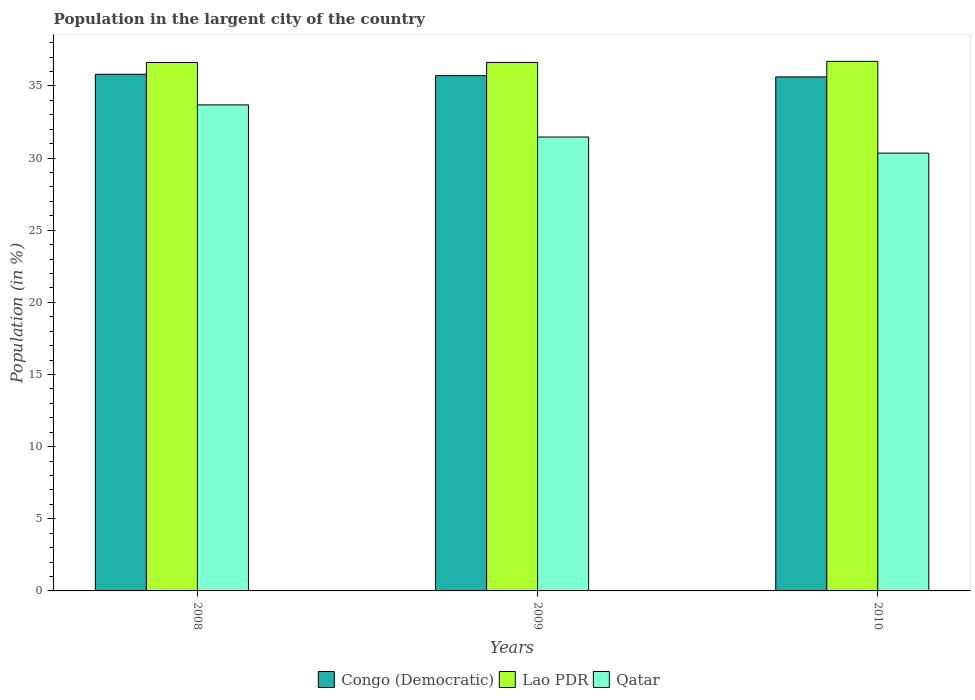How many different coloured bars are there?
Keep it short and to the point. 3. How many groups of bars are there?
Keep it short and to the point. 3. Are the number of bars per tick equal to the number of legend labels?
Make the answer very short. Yes. Are the number of bars on each tick of the X-axis equal?
Your response must be concise. Yes. How many bars are there on the 2nd tick from the right?
Offer a very short reply. 3. What is the label of the 1st group of bars from the left?
Ensure brevity in your answer.  2008. What is the percentage of population in the largent city in Congo (Democratic) in 2008?
Offer a terse response. 35.81. Across all years, what is the maximum percentage of population in the largent city in Congo (Democratic)?
Offer a terse response. 35.81. Across all years, what is the minimum percentage of population in the largent city in Congo (Democratic)?
Offer a terse response. 35.63. In which year was the percentage of population in the largent city in Congo (Democratic) maximum?
Your answer should be compact. 2008. What is the total percentage of population in the largent city in Lao PDR in the graph?
Give a very brief answer. 109.96. What is the difference between the percentage of population in the largent city in Qatar in 2009 and that in 2010?
Your answer should be very brief. 1.12. What is the difference between the percentage of population in the largent city in Lao PDR in 2008 and the percentage of population in the largent city in Congo (Democratic) in 2010?
Offer a terse response. 1. What is the average percentage of population in the largent city in Congo (Democratic) per year?
Provide a succinct answer. 35.72. In the year 2010, what is the difference between the percentage of population in the largent city in Qatar and percentage of population in the largent city in Congo (Democratic)?
Make the answer very short. -5.28. In how many years, is the percentage of population in the largent city in Congo (Democratic) greater than 21 %?
Offer a very short reply. 3. What is the ratio of the percentage of population in the largent city in Lao PDR in 2009 to that in 2010?
Your answer should be very brief. 1. Is the percentage of population in the largent city in Lao PDR in 2008 less than that in 2010?
Keep it short and to the point. Yes. What is the difference between the highest and the second highest percentage of population in the largent city in Qatar?
Your answer should be compact. 2.23. What is the difference between the highest and the lowest percentage of population in the largent city in Lao PDR?
Your response must be concise. 0.08. In how many years, is the percentage of population in the largent city in Qatar greater than the average percentage of population in the largent city in Qatar taken over all years?
Offer a terse response. 1. What does the 1st bar from the left in 2009 represents?
Your answer should be very brief. Congo (Democratic). What does the 3rd bar from the right in 2009 represents?
Make the answer very short. Congo (Democratic). Is it the case that in every year, the sum of the percentage of population in the largent city in Lao PDR and percentage of population in the largent city in Congo (Democratic) is greater than the percentage of population in the largent city in Qatar?
Provide a succinct answer. Yes. How many bars are there?
Your answer should be very brief. 9. What is the difference between two consecutive major ticks on the Y-axis?
Give a very brief answer. 5. Does the graph contain any zero values?
Offer a terse response. No. Does the graph contain grids?
Your response must be concise. No. How many legend labels are there?
Provide a short and direct response. 3. What is the title of the graph?
Give a very brief answer. Population in the largent city of the country. What is the label or title of the X-axis?
Ensure brevity in your answer.  Years. What is the label or title of the Y-axis?
Provide a succinct answer. Population (in %). What is the Population (in %) of Congo (Democratic) in 2008?
Give a very brief answer. 35.81. What is the Population (in %) in Lao PDR in 2008?
Ensure brevity in your answer.  36.62. What is the Population (in %) of Qatar in 2008?
Your answer should be compact. 33.69. What is the Population (in %) of Congo (Democratic) in 2009?
Provide a succinct answer. 35.71. What is the Population (in %) in Lao PDR in 2009?
Provide a short and direct response. 36.63. What is the Population (in %) of Qatar in 2009?
Your answer should be compact. 31.46. What is the Population (in %) in Congo (Democratic) in 2010?
Provide a short and direct response. 35.63. What is the Population (in %) of Lao PDR in 2010?
Provide a succinct answer. 36.7. What is the Population (in %) of Qatar in 2010?
Your answer should be compact. 30.34. Across all years, what is the maximum Population (in %) in Congo (Democratic)?
Your answer should be very brief. 35.81. Across all years, what is the maximum Population (in %) of Lao PDR?
Offer a terse response. 36.7. Across all years, what is the maximum Population (in %) of Qatar?
Keep it short and to the point. 33.69. Across all years, what is the minimum Population (in %) of Congo (Democratic)?
Make the answer very short. 35.63. Across all years, what is the minimum Population (in %) of Lao PDR?
Provide a succinct answer. 36.62. Across all years, what is the minimum Population (in %) of Qatar?
Provide a short and direct response. 30.34. What is the total Population (in %) of Congo (Democratic) in the graph?
Offer a very short reply. 107.15. What is the total Population (in %) of Lao PDR in the graph?
Your answer should be compact. 109.96. What is the total Population (in %) in Qatar in the graph?
Offer a very short reply. 95.49. What is the difference between the Population (in %) of Congo (Democratic) in 2008 and that in 2009?
Your answer should be very brief. 0.09. What is the difference between the Population (in %) of Lao PDR in 2008 and that in 2009?
Make the answer very short. -0.01. What is the difference between the Population (in %) in Qatar in 2008 and that in 2009?
Ensure brevity in your answer.  2.23. What is the difference between the Population (in %) in Congo (Democratic) in 2008 and that in 2010?
Provide a succinct answer. 0.18. What is the difference between the Population (in %) of Lao PDR in 2008 and that in 2010?
Offer a very short reply. -0.08. What is the difference between the Population (in %) of Qatar in 2008 and that in 2010?
Your response must be concise. 3.34. What is the difference between the Population (in %) of Congo (Democratic) in 2009 and that in 2010?
Offer a terse response. 0.09. What is the difference between the Population (in %) of Lao PDR in 2009 and that in 2010?
Your answer should be very brief. -0.07. What is the difference between the Population (in %) of Qatar in 2009 and that in 2010?
Offer a terse response. 1.12. What is the difference between the Population (in %) in Congo (Democratic) in 2008 and the Population (in %) in Lao PDR in 2009?
Keep it short and to the point. -0.82. What is the difference between the Population (in %) of Congo (Democratic) in 2008 and the Population (in %) of Qatar in 2009?
Your answer should be compact. 4.35. What is the difference between the Population (in %) in Lao PDR in 2008 and the Population (in %) in Qatar in 2009?
Make the answer very short. 5.16. What is the difference between the Population (in %) of Congo (Democratic) in 2008 and the Population (in %) of Lao PDR in 2010?
Your answer should be very brief. -0.9. What is the difference between the Population (in %) of Congo (Democratic) in 2008 and the Population (in %) of Qatar in 2010?
Provide a short and direct response. 5.47. What is the difference between the Population (in %) of Lao PDR in 2008 and the Population (in %) of Qatar in 2010?
Ensure brevity in your answer.  6.28. What is the difference between the Population (in %) in Congo (Democratic) in 2009 and the Population (in %) in Lao PDR in 2010?
Offer a terse response. -0.99. What is the difference between the Population (in %) of Congo (Democratic) in 2009 and the Population (in %) of Qatar in 2010?
Ensure brevity in your answer.  5.37. What is the difference between the Population (in %) of Lao PDR in 2009 and the Population (in %) of Qatar in 2010?
Provide a short and direct response. 6.29. What is the average Population (in %) of Congo (Democratic) per year?
Provide a short and direct response. 35.72. What is the average Population (in %) in Lao PDR per year?
Make the answer very short. 36.65. What is the average Population (in %) in Qatar per year?
Provide a short and direct response. 31.83. In the year 2008, what is the difference between the Population (in %) in Congo (Democratic) and Population (in %) in Lao PDR?
Your answer should be very brief. -0.82. In the year 2008, what is the difference between the Population (in %) of Congo (Democratic) and Population (in %) of Qatar?
Provide a short and direct response. 2.12. In the year 2008, what is the difference between the Population (in %) in Lao PDR and Population (in %) in Qatar?
Provide a short and direct response. 2.94. In the year 2009, what is the difference between the Population (in %) in Congo (Democratic) and Population (in %) in Lao PDR?
Keep it short and to the point. -0.92. In the year 2009, what is the difference between the Population (in %) in Congo (Democratic) and Population (in %) in Qatar?
Provide a short and direct response. 4.25. In the year 2009, what is the difference between the Population (in %) of Lao PDR and Population (in %) of Qatar?
Ensure brevity in your answer.  5.17. In the year 2010, what is the difference between the Population (in %) in Congo (Democratic) and Population (in %) in Lao PDR?
Ensure brevity in your answer.  -1.08. In the year 2010, what is the difference between the Population (in %) in Congo (Democratic) and Population (in %) in Qatar?
Make the answer very short. 5.28. In the year 2010, what is the difference between the Population (in %) in Lao PDR and Population (in %) in Qatar?
Ensure brevity in your answer.  6.36. What is the ratio of the Population (in %) in Congo (Democratic) in 2008 to that in 2009?
Make the answer very short. 1. What is the ratio of the Population (in %) in Lao PDR in 2008 to that in 2009?
Your answer should be compact. 1. What is the ratio of the Population (in %) of Qatar in 2008 to that in 2009?
Your answer should be compact. 1.07. What is the ratio of the Population (in %) of Qatar in 2008 to that in 2010?
Keep it short and to the point. 1.11. What is the ratio of the Population (in %) of Qatar in 2009 to that in 2010?
Your answer should be compact. 1.04. What is the difference between the highest and the second highest Population (in %) in Congo (Democratic)?
Offer a very short reply. 0.09. What is the difference between the highest and the second highest Population (in %) of Lao PDR?
Provide a short and direct response. 0.07. What is the difference between the highest and the second highest Population (in %) in Qatar?
Your response must be concise. 2.23. What is the difference between the highest and the lowest Population (in %) in Congo (Democratic)?
Make the answer very short. 0.18. What is the difference between the highest and the lowest Population (in %) in Lao PDR?
Ensure brevity in your answer.  0.08. What is the difference between the highest and the lowest Population (in %) in Qatar?
Ensure brevity in your answer.  3.34. 